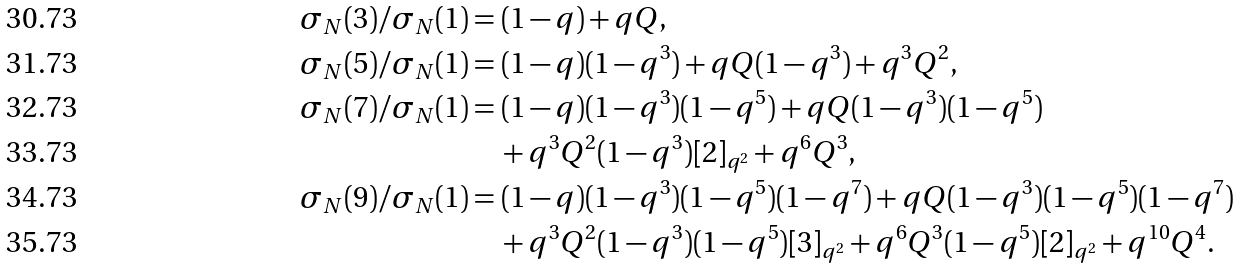<formula> <loc_0><loc_0><loc_500><loc_500>\sigma _ { N } ( 3 ) / \sigma _ { N } ( 1 ) & = ( 1 - q ) + q Q , \\ \sigma _ { N } ( 5 ) / \sigma _ { N } ( 1 ) & = ( 1 - q ) ( 1 - q ^ { 3 } ) + q Q ( 1 - q ^ { 3 } ) + q ^ { 3 } Q ^ { 2 } , \\ \sigma _ { N } ( 7 ) / \sigma _ { N } ( 1 ) & = ( 1 - q ) ( 1 - q ^ { 3 } ) ( 1 - q ^ { 5 } ) + q Q ( 1 - q ^ { 3 } ) ( 1 - q ^ { 5 } ) \\ & \quad + q ^ { 3 } Q ^ { 2 } ( 1 - q ^ { 3 } ) [ 2 ] _ { q ^ { 2 } } + q ^ { 6 } Q ^ { 3 } , \\ \sigma _ { N } ( 9 ) / \sigma _ { N } ( 1 ) & = ( 1 - q ) ( 1 - q ^ { 3 } ) ( 1 - q ^ { 5 } ) ( 1 - q ^ { 7 } ) + q Q ( 1 - q ^ { 3 } ) ( 1 - q ^ { 5 } ) ( 1 - q ^ { 7 } ) \\ & \quad + q ^ { 3 } Q ^ { 2 } ( 1 - q ^ { 3 } ) ( 1 - q ^ { 5 } ) [ 3 ] _ { q ^ { 2 } } + q ^ { 6 } Q ^ { 3 } ( 1 - q ^ { 5 } ) [ 2 ] _ { q ^ { 2 } } + q ^ { 1 0 } Q ^ { 4 } .</formula> 